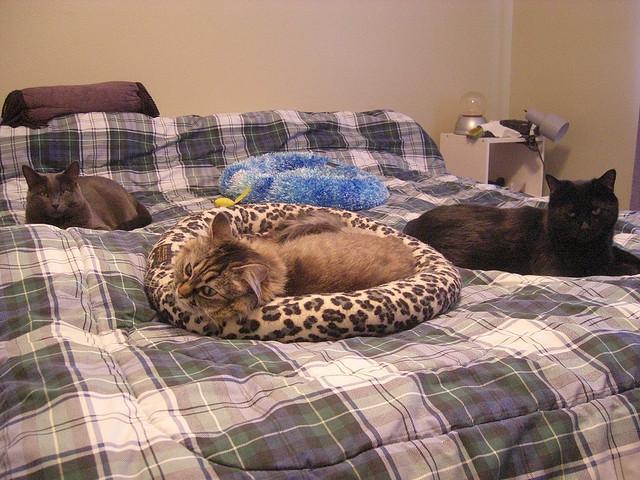How many cats are there?
Give a very brief answer. 3. 